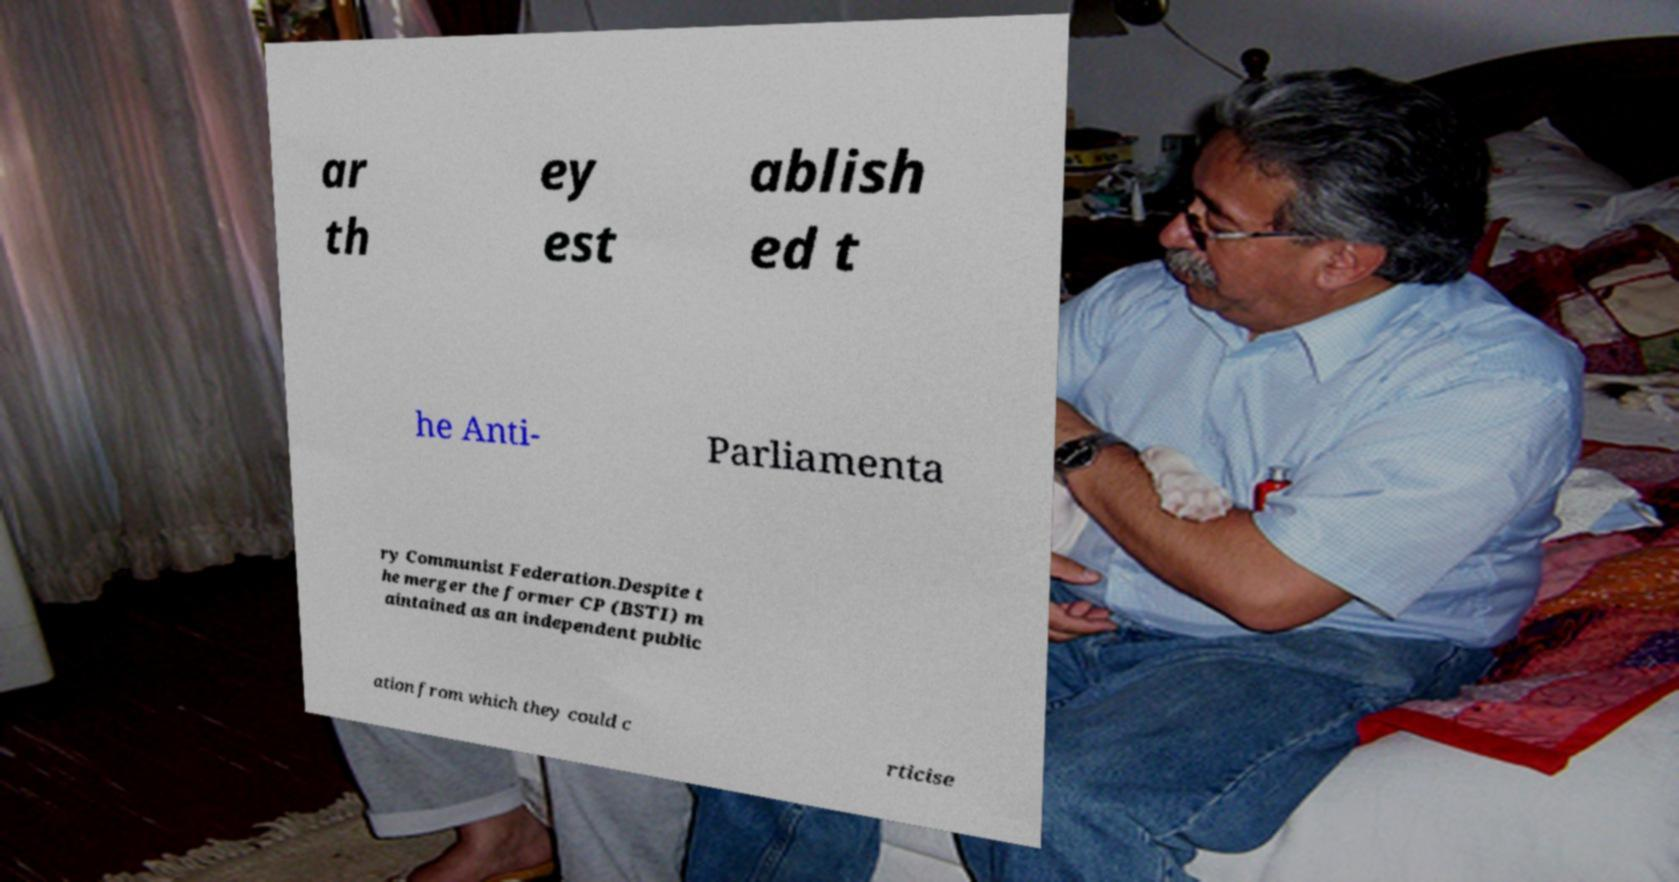Could you extract and type out the text from this image? ar th ey est ablish ed t he Anti- Parliamenta ry Communist Federation.Despite t he merger the former CP (BSTI) m aintained as an independent public ation from which they could c rticise 